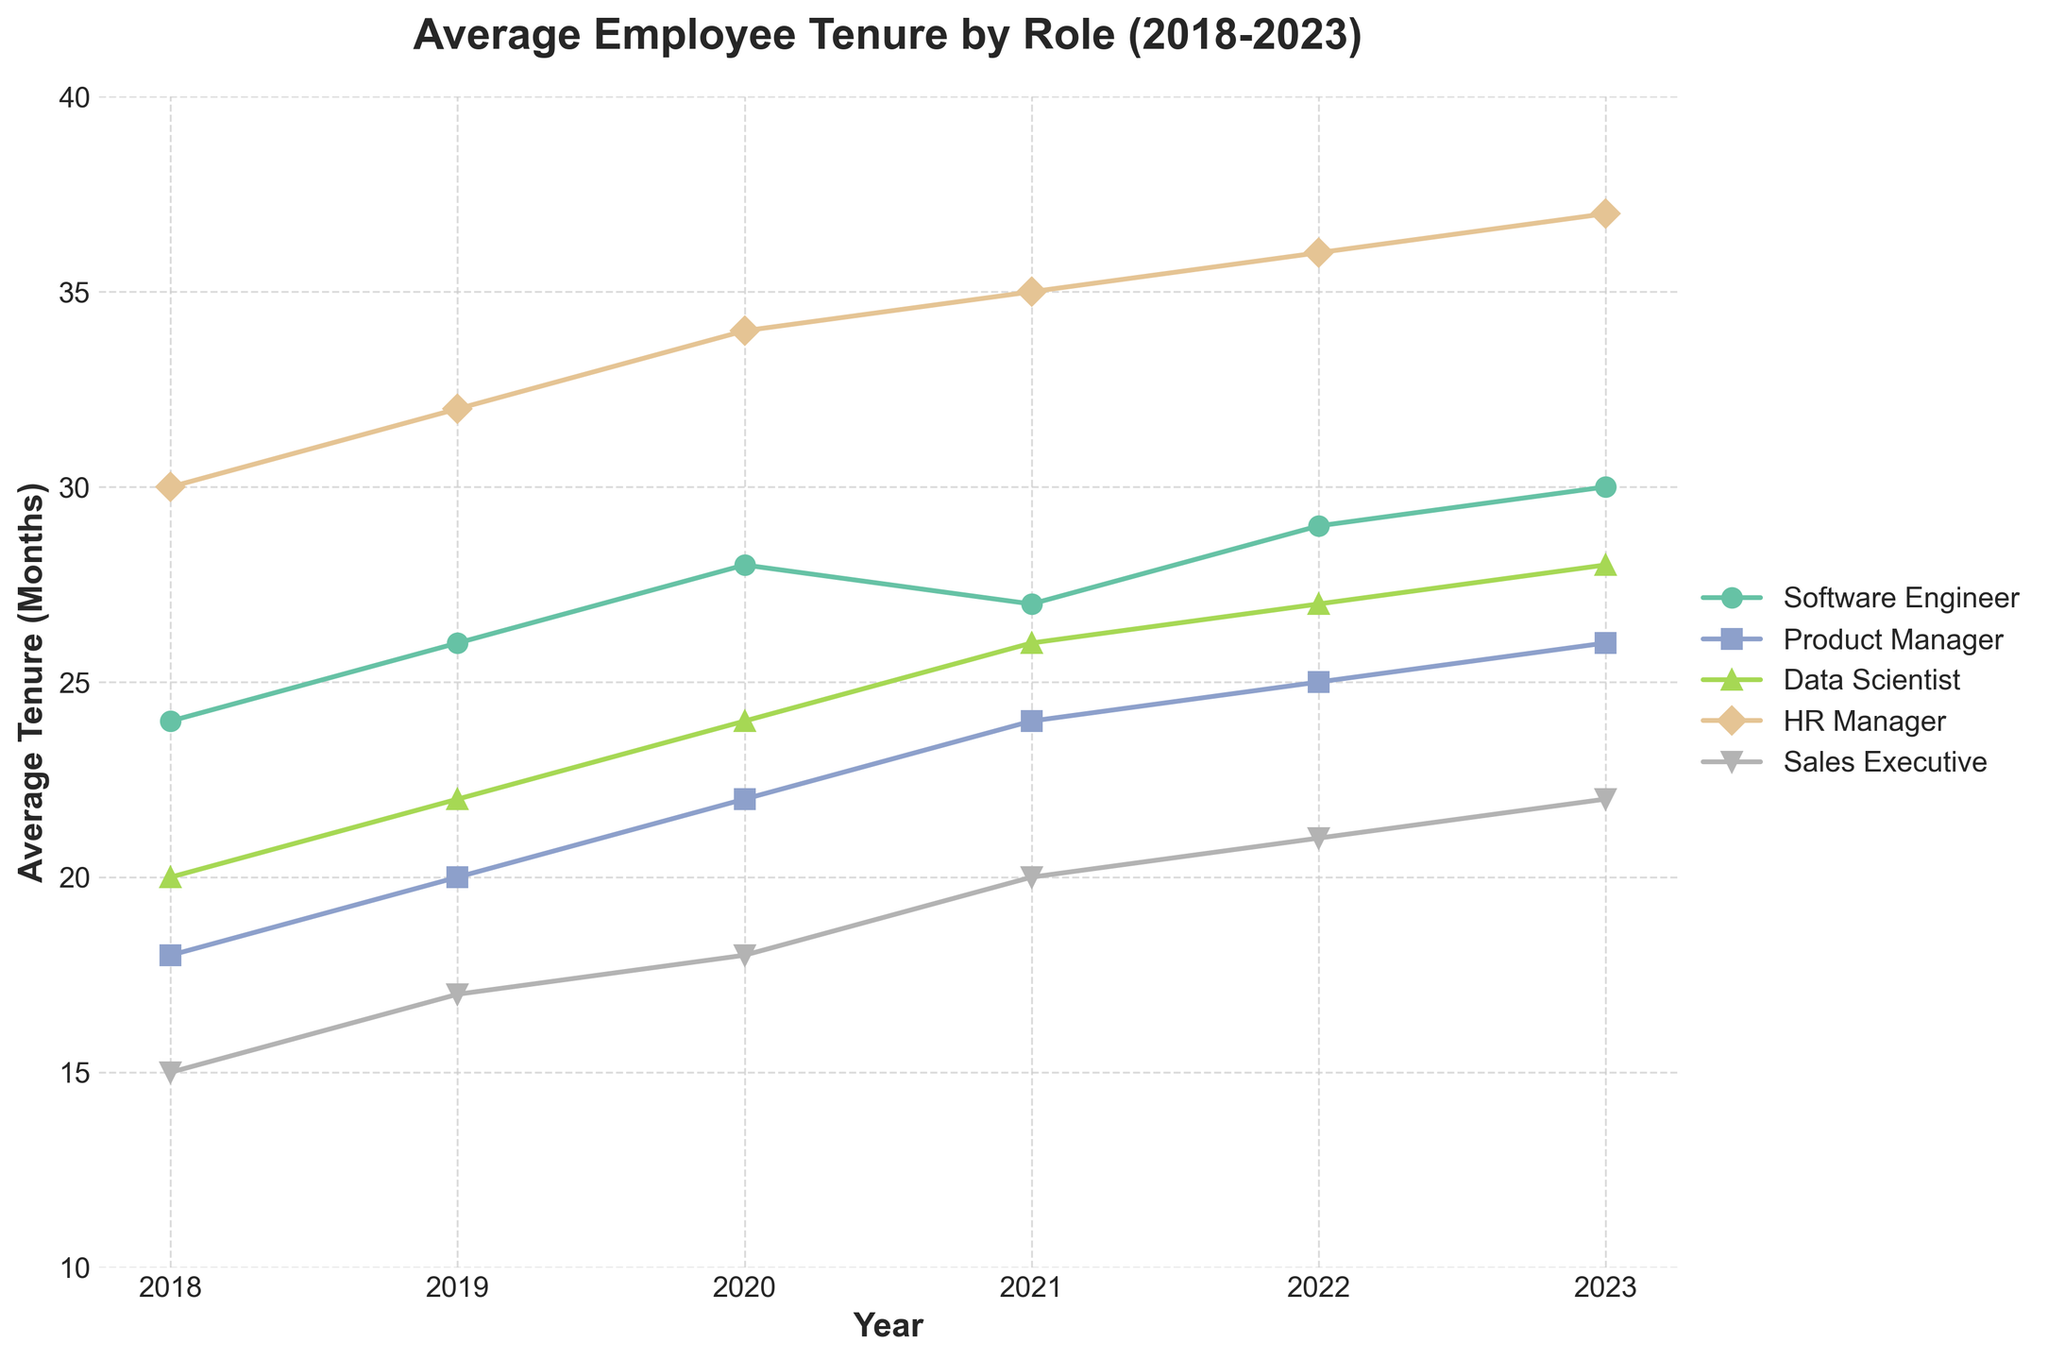what is the role with the shortest average tenure in 2018? In the time series plot, find the data point for 2018 and compare the average tenure values for each role. The role with the smallest value will have the shortest average tenure.
Answer: Sales Executive which role saw the greatest increase in average tenure from 2018 to 2023? Locate the starting and ending points for each role from 2018 to 2023 and calculate the change in average tenure. Compare the changes for all roles to find the maximum increase.
Answer: Data Scientist what is the average tenure of Product Managers in 2021? Identify the data point for Product Manager in 2021 from the plot and read off the value on the y-axis.
Answer: 24 months which year did Software Engineers see a plateau in their average tenure? Observe the trend line for Software Engineers and identify any year or periods where the average tenure remains nearly constant without significant upward or downward movement.
Answer: 2021 which role consistently had the highest average tenure over the time period? Compare the trend lines for each role and identify which one's average tenure values are consistently higher than others across all years.
Answer: HR Manager 